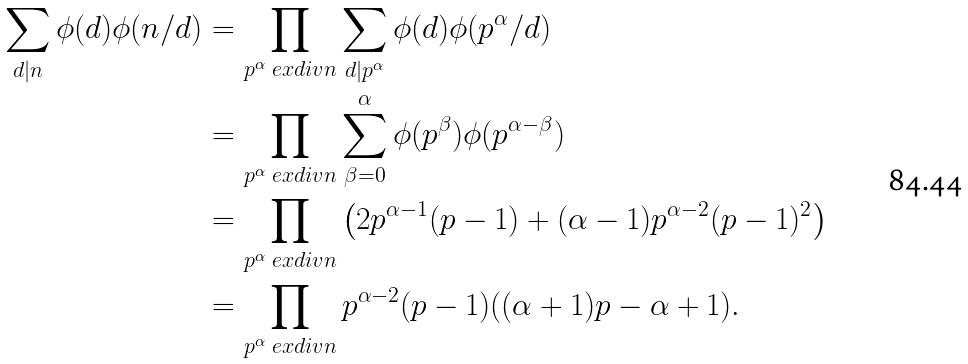Convert formula to latex. <formula><loc_0><loc_0><loc_500><loc_500>\sum _ { d | n } \phi ( d ) \phi ( n / d ) & = \prod _ { p ^ { \alpha } \ e x d i v n } \sum _ { d | p ^ { \alpha } } \phi ( d ) \phi ( p ^ { \alpha } / d ) \\ & = \prod _ { p ^ { \alpha } \ e x d i v n } \sum _ { \beta = 0 } ^ { \alpha } \phi ( p ^ { \beta } ) \phi ( p ^ { \alpha - \beta } ) \\ & = \prod _ { p ^ { \alpha } \ e x d i v n } \left ( 2 p ^ { \alpha - 1 } ( p - 1 ) + ( \alpha - 1 ) p ^ { \alpha - 2 } ( p - 1 ) ^ { 2 } \right ) \\ & = \prod _ { p ^ { \alpha } \ e x d i v n } p ^ { \alpha - 2 } ( p - 1 ) ( ( \alpha + 1 ) p - \alpha + 1 ) .</formula> 